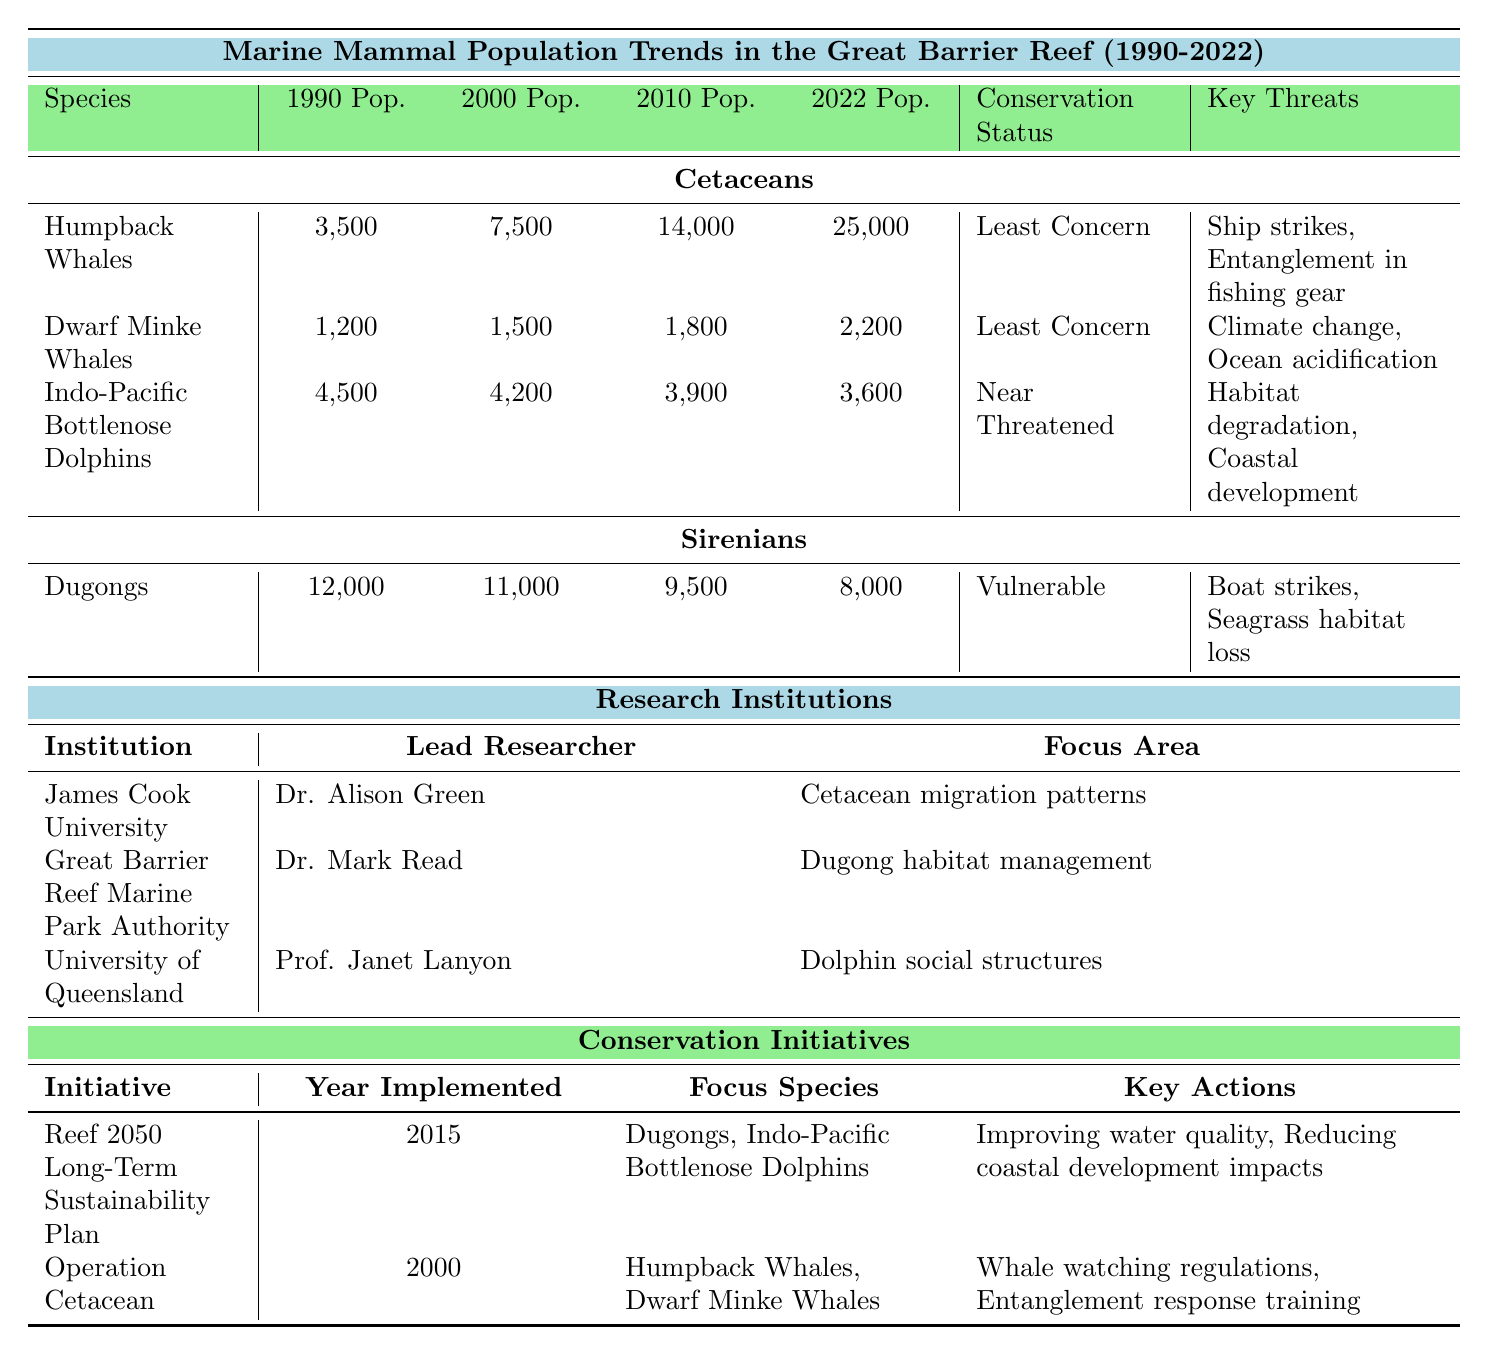What was the population of Humpback Whales in 2010? The table shows the population of Humpback Whales for various years, and for 2010, the value is explicitly listed as 14,000.
Answer: 14,000 How many Dugongs were recorded in 2022? According to the data in the table, the population of Dugongs in 2022 is stated as 8,000.
Answer: 8,000 Which species has seen a decrease in population from 1990 to 2022, according to the table? By examining the populations over these years, Dugongs decreased from 12,000 in 1990 to 8,000 in 2022, showing a decline. Humpback Whales and others increased in population.
Answer: Dugongs What was the total population of Dugongs in 1990 and 2000 combined? The populations of Dugongs for those years are 12,000 (1990) and 11,000 (2000). Adding these gives 12,000 + 11,000 = 23,000.
Answer: 23,000 Are Indo-Pacific Bottlenose Dolphins classified as "Vulnerable"? The table indicates that the conservation status of Indo-Pacific Bottlenose Dolphins is "Near Threatened," rather than "Vulnerable", making this statement false.
Answer: No How has the population trend of Dwarf Minke Whales changed between 1990 and 2022? Since the population increased from 1,200 in 1990 to 2,200 in 2022, we can conclude that the Dwarf Minke Whales have had a positive population trend over this period.
Answer: Increased What are the key threats to Humpback Whales as per the table? The table explicitly lists the threats to Humpback Whales as "Ship strikes" and "Entanglement in fishing gear."
Answer: Ship strikes, Entanglement in fishing gear What is the average population of Dugongs from 1990 to 2022? To find the average, we add the populations across the years: 12,000 + 11,000 + 9,500 + 8,000 = 40,500. Then divide by the number of years (4), giving us 40,500 / 4 = 10,125.
Answer: 10,125 Which research institution focuses on Dugong habitat management? The table states that the Great Barrier Reef Marine Park Authority is led by Dr. Mark Read and focuses on Dugong habitat management.
Answer: Great Barrier Reef Marine Park Authority What conservation status is assigned to the Indo-Pacific Bottlenose Dolphins? The table clearly indicates that Indo-Pacific Bottlenose Dolphins are classified as "Near Threatened."
Answer: Near Threatened Which conservation initiative was implemented in 2015? According to the table, the Reef 2050 Long-Term Sustainability Plan was implemented in 2015.
Answer: Reef 2050 Long-Term Sustainability Plan 